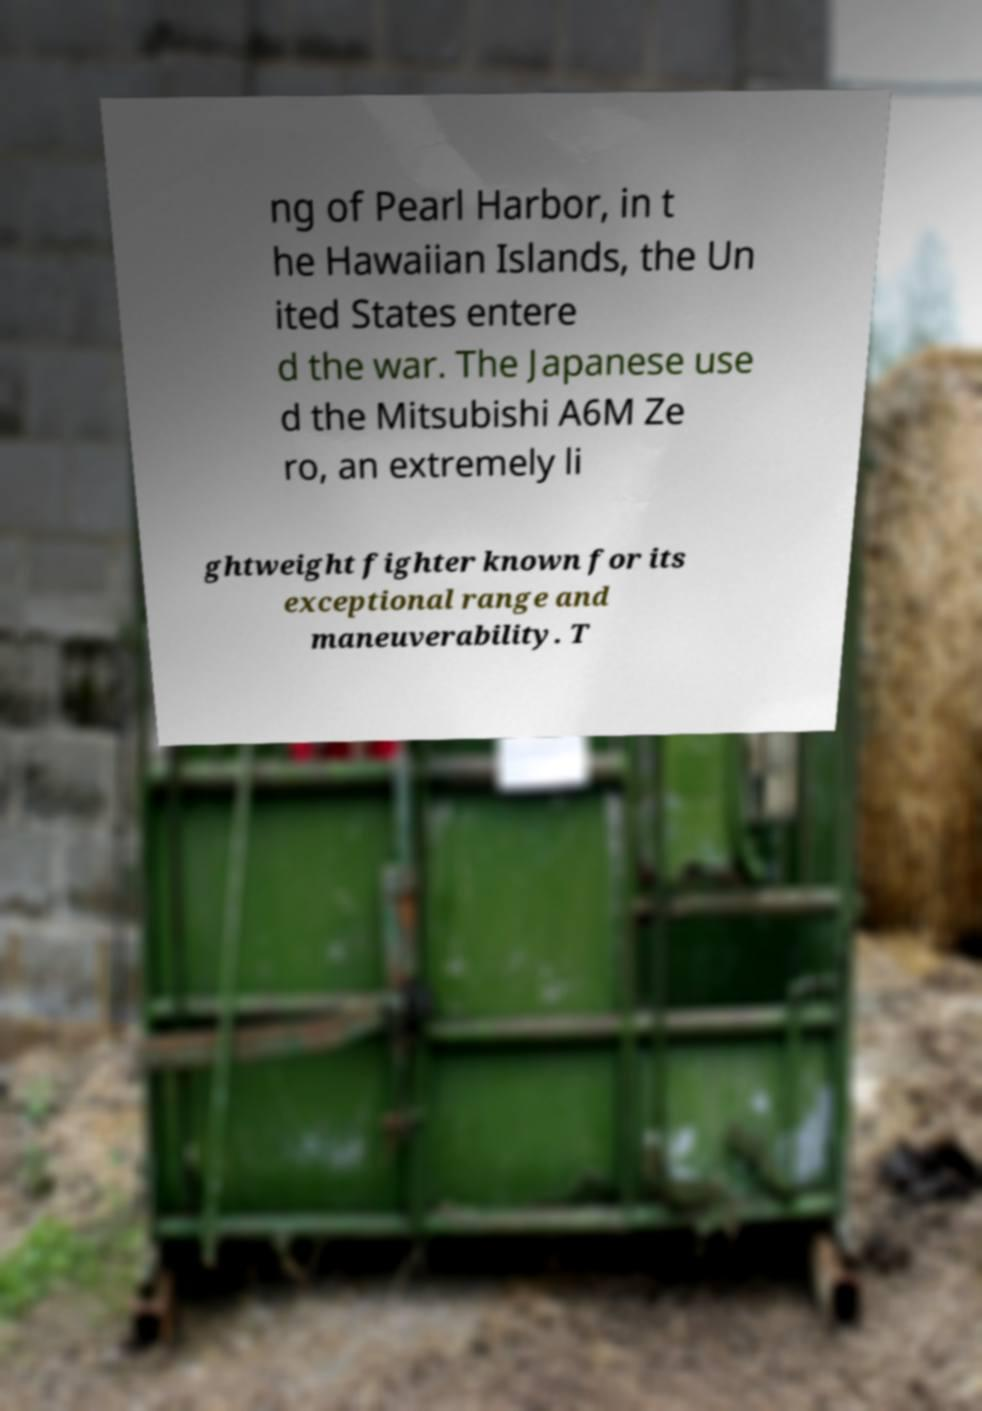Please identify and transcribe the text found in this image. ng of Pearl Harbor, in t he Hawaiian Islands, the Un ited States entere d the war. The Japanese use d the Mitsubishi A6M Ze ro, an extremely li ghtweight fighter known for its exceptional range and maneuverability. T 